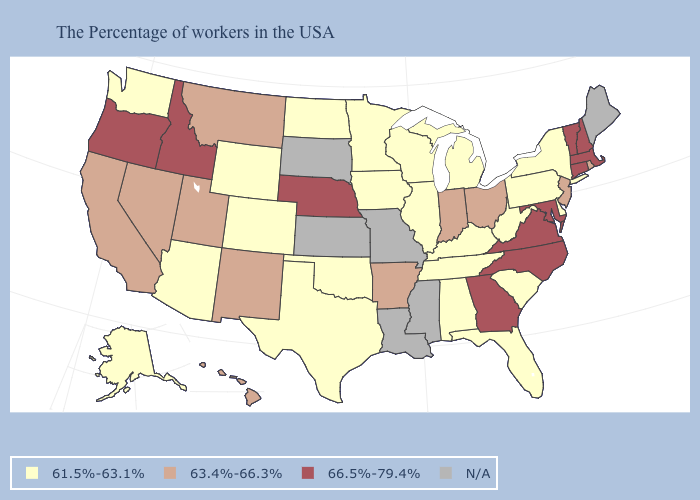What is the value of Wyoming?
Be succinct. 61.5%-63.1%. Does the map have missing data?
Answer briefly. Yes. What is the highest value in the USA?
Concise answer only. 66.5%-79.4%. Does Michigan have the lowest value in the MidWest?
Answer briefly. Yes. Name the states that have a value in the range 61.5%-63.1%?
Answer briefly. New York, Delaware, Pennsylvania, South Carolina, West Virginia, Florida, Michigan, Kentucky, Alabama, Tennessee, Wisconsin, Illinois, Minnesota, Iowa, Oklahoma, Texas, North Dakota, Wyoming, Colorado, Arizona, Washington, Alaska. Does the map have missing data?
Keep it brief. Yes. What is the value of North Dakota?
Give a very brief answer. 61.5%-63.1%. What is the value of New Hampshire?
Quick response, please. 66.5%-79.4%. What is the highest value in the South ?
Quick response, please. 66.5%-79.4%. What is the highest value in states that border Massachusetts?
Give a very brief answer. 66.5%-79.4%. Which states have the highest value in the USA?
Give a very brief answer. Massachusetts, New Hampshire, Vermont, Connecticut, Maryland, Virginia, North Carolina, Georgia, Nebraska, Idaho, Oregon. Does the first symbol in the legend represent the smallest category?
Give a very brief answer. Yes. What is the lowest value in the USA?
Be succinct. 61.5%-63.1%. 